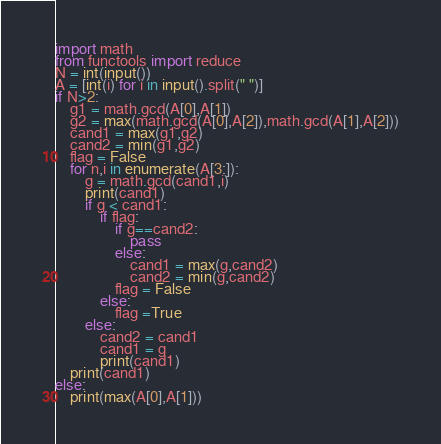<code> <loc_0><loc_0><loc_500><loc_500><_Python_>import math
from functools import reduce
N = int(input())
A = [int(i) for i in input().split(" ")]
if N>2:
    g1 = math.gcd(A[0],A[1])
    g2 = max(math.gcd(A[0],A[2]),math.gcd(A[1],A[2]))
    cand1 = max(g1,g2)
    cand2 = min(g1,g2)
    flag = False
    for n,i in enumerate(A[3:]):
        g = math.gcd(cand1,i)
        print(cand1)
        if g < cand1:
            if flag:
                if g==cand2:
                    pass
                else:
                    cand1 = max(g,cand2)
                    cand2 = min(g,cand2)
                flag = False
            else:
                flag =True
        else:
            cand2 = cand1
            cand1 = g
            print(cand1)
    print(cand1)
else:
    print(max(A[0],A[1]))</code> 